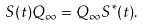Convert formula to latex. <formula><loc_0><loc_0><loc_500><loc_500>S ( t ) Q _ { \infty } = Q _ { \infty } S ^ { * } ( t ) .</formula> 